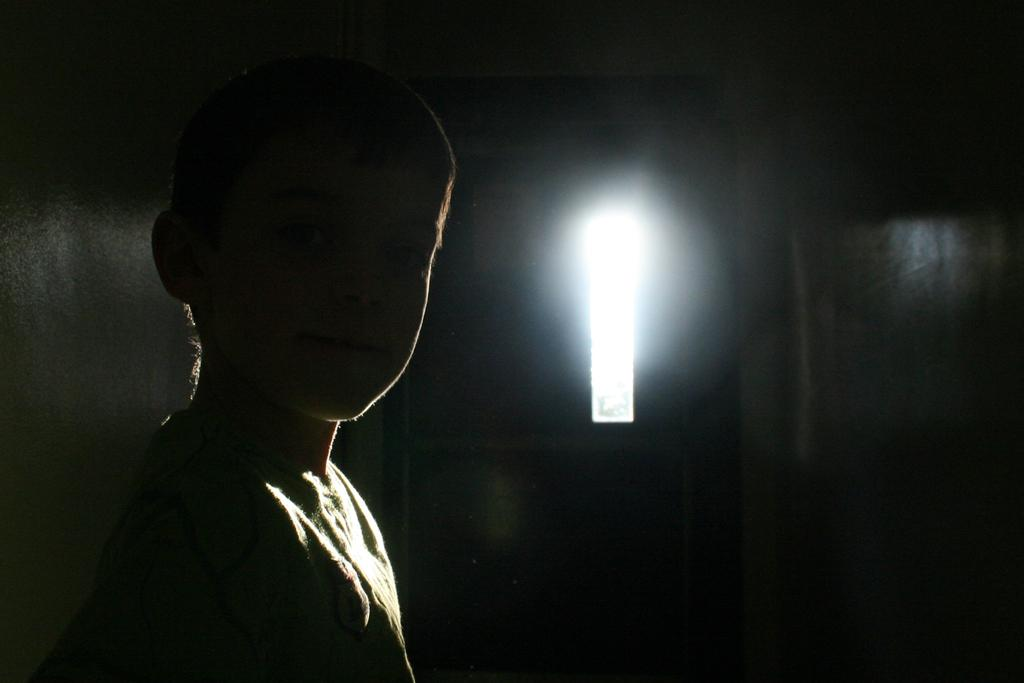Who or what is present in the image? There is a person in the image. Where is the person located? The person is inside a room. Can you describe the lighting conditions in the image? There is light visible in the background of the image. What type of twig can be seen in the image? There is no twig present in the image. What kind of border is visible around the person in the image? The image does not show any borders around the person. 